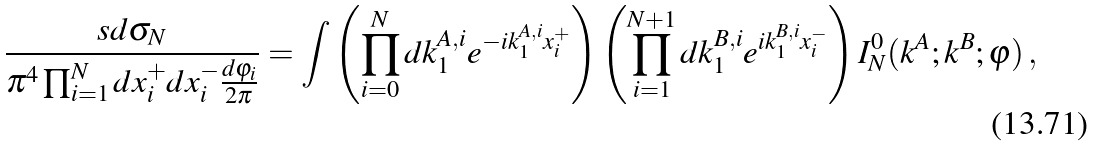<formula> <loc_0><loc_0><loc_500><loc_500>\frac { s d \sigma _ { N } } { \pi ^ { 4 } \prod _ { i = 1 } ^ { N } d x _ { i } ^ { + } d x _ { i } ^ { - } \frac { d \varphi _ { i } } { 2 \pi } } = \int \left ( \prod _ { i = 0 } ^ { N } d k ^ { A , i } _ { 1 } e ^ { - i k ^ { A , i } _ { 1 } x ^ { + } _ { i } } \right ) \left ( \prod _ { i = 1 } ^ { N + 1 } d k ^ { B , i } _ { 1 } e ^ { i k ^ { B , i } _ { 1 } x ^ { - } _ { i } } \right ) I _ { N } ^ { 0 } ( k ^ { A } ; k ^ { B } ; \varphi ) \, ,</formula> 